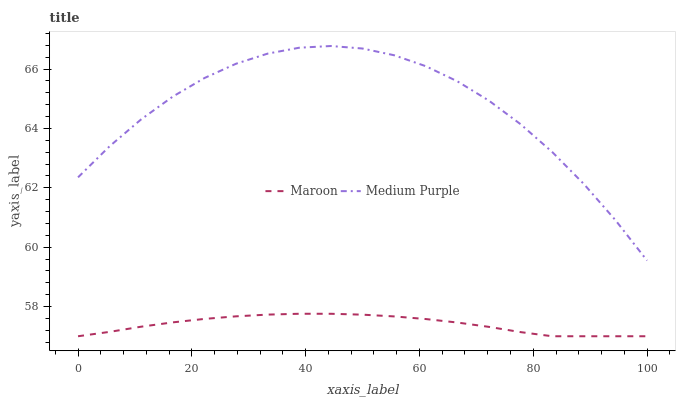Does Maroon have the maximum area under the curve?
Answer yes or no. No. Is Maroon the roughest?
Answer yes or no. No. Does Maroon have the highest value?
Answer yes or no. No. Is Maroon less than Medium Purple?
Answer yes or no. Yes. Is Medium Purple greater than Maroon?
Answer yes or no. Yes. Does Maroon intersect Medium Purple?
Answer yes or no. No. 